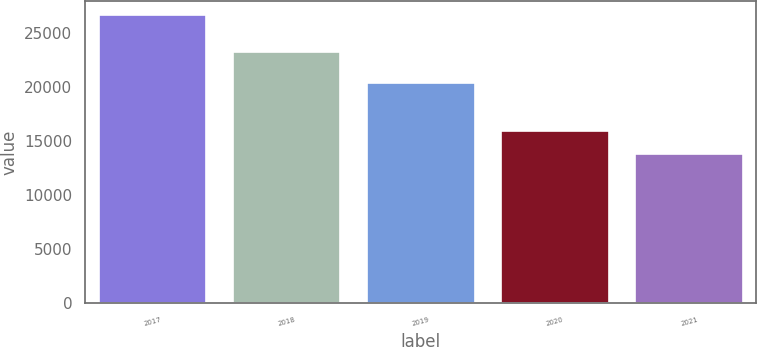Convert chart. <chart><loc_0><loc_0><loc_500><loc_500><bar_chart><fcel>2017<fcel>2018<fcel>2019<fcel>2020<fcel>2021<nl><fcel>26630<fcel>23219<fcel>20339<fcel>15937<fcel>13774<nl></chart> 